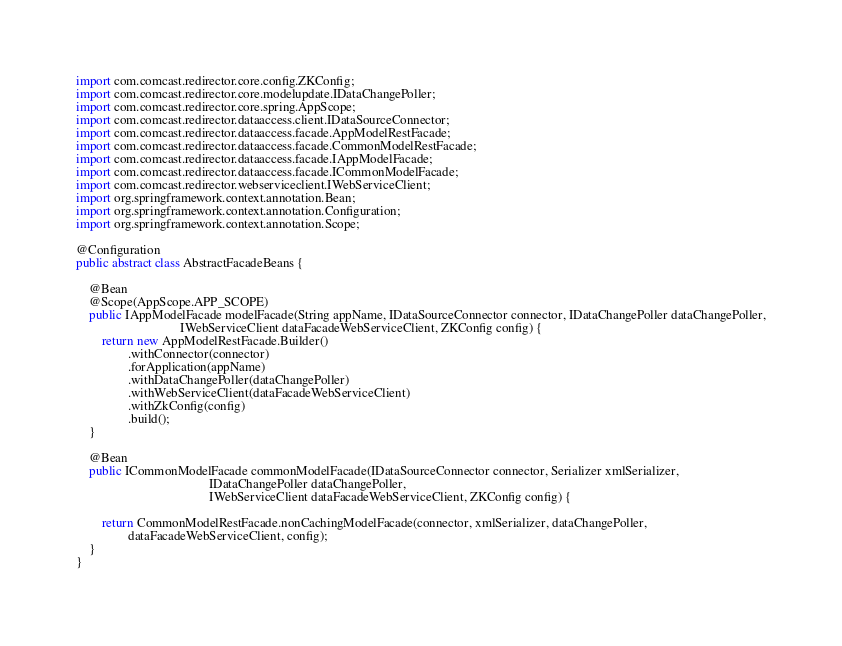Convert code to text. <code><loc_0><loc_0><loc_500><loc_500><_Java_>import com.comcast.redirector.core.config.ZKConfig;
import com.comcast.redirector.core.modelupdate.IDataChangePoller;
import com.comcast.redirector.core.spring.AppScope;
import com.comcast.redirector.dataaccess.client.IDataSourceConnector;
import com.comcast.redirector.dataaccess.facade.AppModelRestFacade;
import com.comcast.redirector.dataaccess.facade.CommonModelRestFacade;
import com.comcast.redirector.dataaccess.facade.IAppModelFacade;
import com.comcast.redirector.dataaccess.facade.ICommonModelFacade;
import com.comcast.redirector.webserviceclient.IWebServiceClient;
import org.springframework.context.annotation.Bean;
import org.springframework.context.annotation.Configuration;
import org.springframework.context.annotation.Scope;

@Configuration
public abstract class AbstractFacadeBeans {

    @Bean
    @Scope(AppScope.APP_SCOPE)
    public IAppModelFacade modelFacade(String appName, IDataSourceConnector connector, IDataChangePoller dataChangePoller,
                                IWebServiceClient dataFacadeWebServiceClient, ZKConfig config) {
        return new AppModelRestFacade.Builder()
                .withConnector(connector)
                .forApplication(appName)
                .withDataChangePoller(dataChangePoller)
                .withWebServiceClient(dataFacadeWebServiceClient)
                .withZkConfig(config)
                .build();
    }

    @Bean
    public ICommonModelFacade commonModelFacade(IDataSourceConnector connector, Serializer xmlSerializer,
                                         IDataChangePoller dataChangePoller,
                                         IWebServiceClient dataFacadeWebServiceClient, ZKConfig config) {

        return CommonModelRestFacade.nonCachingModelFacade(connector, xmlSerializer, dataChangePoller,
                dataFacadeWebServiceClient, config);
    }
}
</code> 